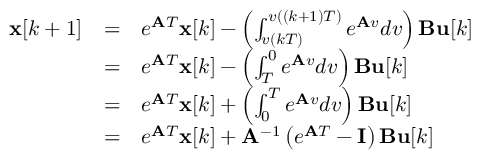Convert formula to latex. <formula><loc_0><loc_0><loc_500><loc_500>{ \begin{array} { l l l } { x [ k + 1 ] } & { = } & { e ^ { A T } x [ k ] - \left ( \int _ { v ( k T ) } ^ { v ( ( k + 1 ) T ) } e ^ { A v } d v \right ) B u [ k ] } \\ & { = } & { e ^ { A T } x [ k ] - \left ( \int _ { T } ^ { 0 } e ^ { A v } d v \right ) B u [ k ] } \\ & { = } & { e ^ { A T } x [ k ] + \left ( \int _ { 0 } ^ { T } e ^ { A v } d v \right ) B u [ k ] } \\ & { = } & { e ^ { A T } x [ k ] + A ^ { - 1 } \left ( e ^ { A T } - I \right ) B u [ k ] } \end{array} }</formula> 